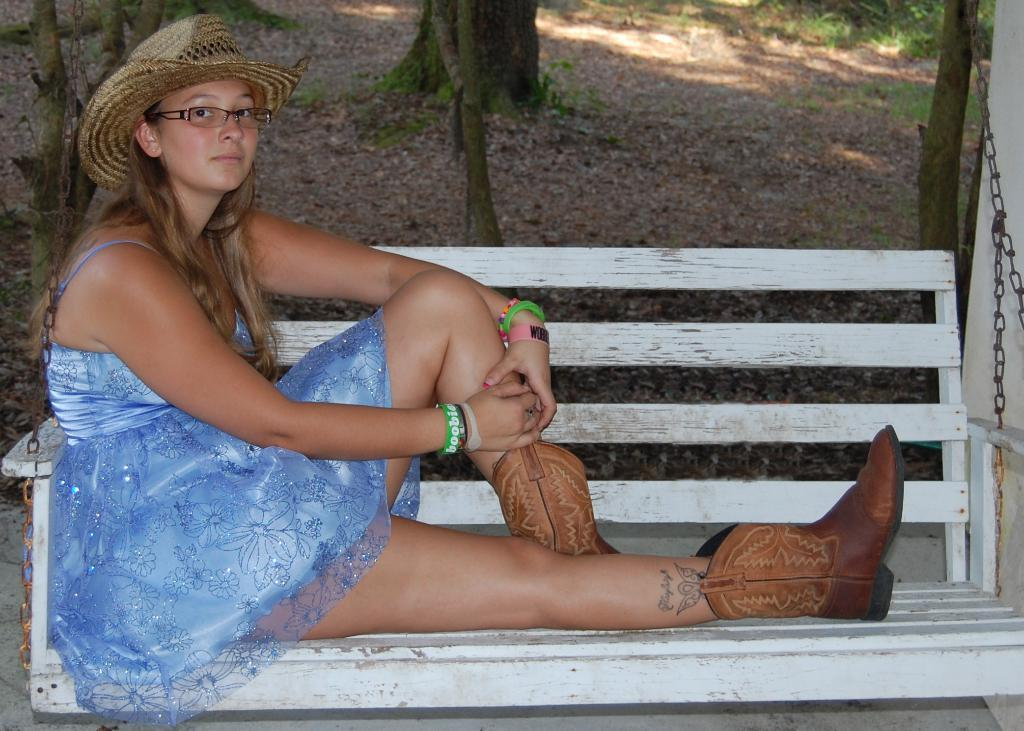Who is the main subject in the image? There is a woman in the image. What is the woman wearing? The woman is wearing a blue frock, boots, and a hat. What is the woman doing in the image? The woman is sitting on a bench. What can be seen behind the bench? There are trees visible behind the bench. What is the location of the trees? The trees are on land. What type of development is taking place in the image? There is no development or construction activity visible in the image. What color is the shoe the woman is wearing? The woman is wearing boots, not shoes, and their color is not mentioned in the facts. 